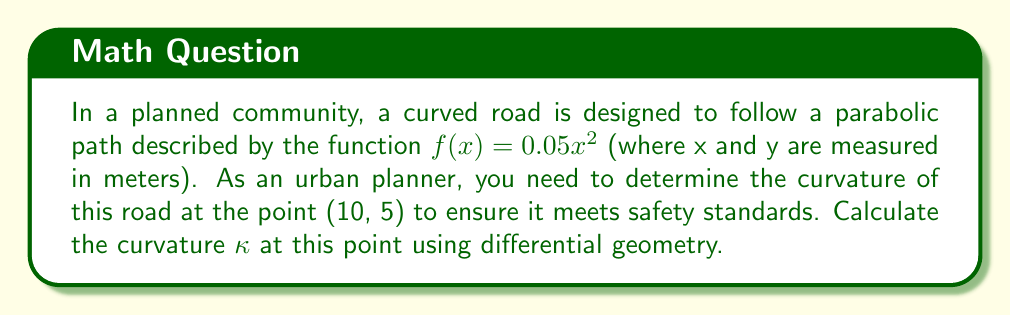Could you help me with this problem? To calculate the curvature κ of the road at the point (10, 5), we'll follow these steps:

1. The formula for curvature of a function y = f(x) is:

   $$κ = \frac{|f''(x)|}{(1 + [f'(x)]^2)^{3/2}}$$

2. First, we need to find f'(x) and f''(x):
   
   $$f(x) = 0.05x^2$$
   $$f'(x) = 0.1x$$
   $$f''(x) = 0.1$$

3. At the point (10, 5), x = 10. Let's substitute this into f'(x):
   
   $$f'(10) = 0.1 * 10 = 1$$

4. Now we can substitute these values into the curvature formula:

   $$κ = \frac{|0.1|}{(1 + [1]^2)^{3/2}}$$

5. Simplify:
   
   $$κ = \frac{0.1}{(1 + 1)^{3/2}} = \frac{0.1}{2^{3/2}} = \frac{0.1}{2\sqrt{2}}$$

6. To get a decimal approximation:
   
   $$κ ≈ 0.0354 \text{ m}^{-1}$$

This curvature value represents the reciprocal of the radius of the osculating circle at the given point, providing a measure of how sharply the road curves at (10, 5).
Answer: $κ = \frac{0.1}{2\sqrt{2}} ≈ 0.0354 \text{ m}^{-1}$ 